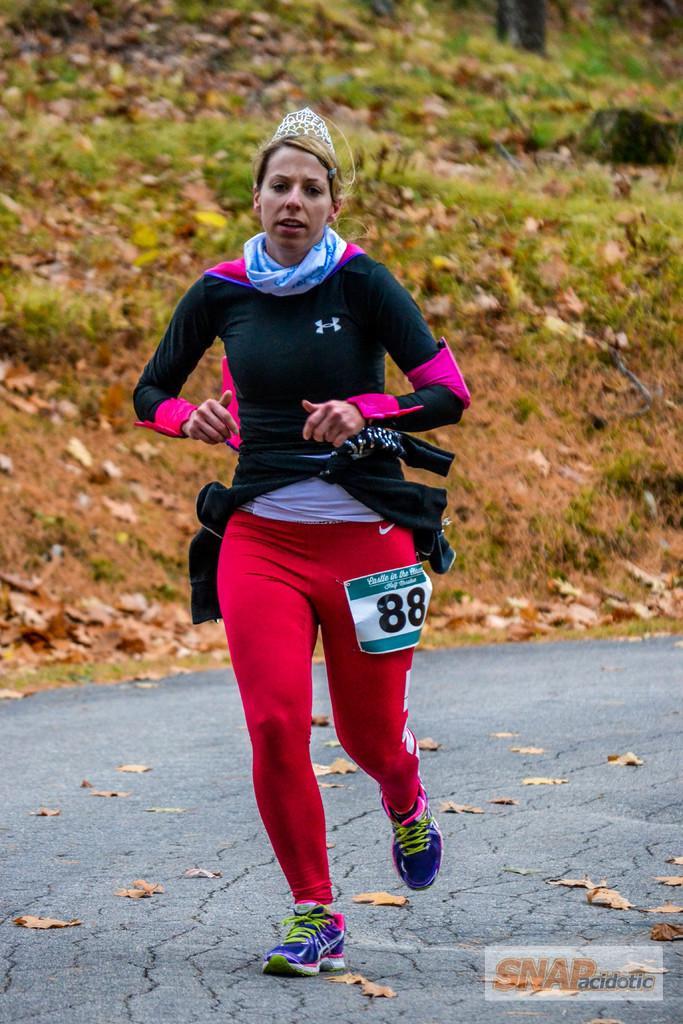In one or two sentences, can you explain what this image depicts? In this image we can see a person running on the road. In the background, we can see the leaves and grass. And at the bottom there is a text written on the poster. 